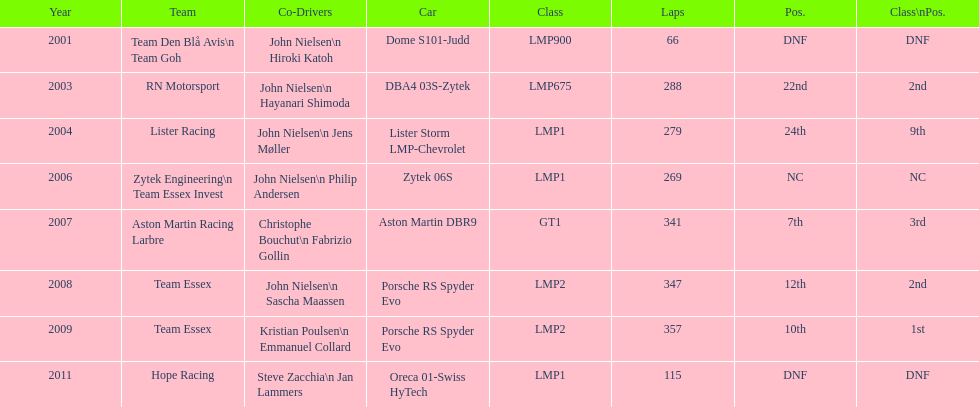What model car was the most used? Porsche RS Spyder. Could you parse the entire table? {'header': ['Year', 'Team', 'Co-Drivers', 'Car', 'Class', 'Laps', 'Pos.', 'Class\\nPos.'], 'rows': [['2001', 'Team Den Blå Avis\\n Team Goh', 'John Nielsen\\n Hiroki Katoh', 'Dome S101-Judd', 'LMP900', '66', 'DNF', 'DNF'], ['2003', 'RN Motorsport', 'John Nielsen\\n Hayanari Shimoda', 'DBA4 03S-Zytek', 'LMP675', '288', '22nd', '2nd'], ['2004', 'Lister Racing', 'John Nielsen\\n Jens Møller', 'Lister Storm LMP-Chevrolet', 'LMP1', '279', '24th', '9th'], ['2006', 'Zytek Engineering\\n Team Essex Invest', 'John Nielsen\\n Philip Andersen', 'Zytek 06S', 'LMP1', '269', 'NC', 'NC'], ['2007', 'Aston Martin Racing Larbre', 'Christophe Bouchut\\n Fabrizio Gollin', 'Aston Martin DBR9', 'GT1', '341', '7th', '3rd'], ['2008', 'Team Essex', 'John Nielsen\\n Sascha Maassen', 'Porsche RS Spyder Evo', 'LMP2', '347', '12th', '2nd'], ['2009', 'Team Essex', 'Kristian Poulsen\\n Emmanuel Collard', 'Porsche RS Spyder Evo', 'LMP2', '357', '10th', '1st'], ['2011', 'Hope Racing', 'Steve Zacchia\\n Jan Lammers', 'Oreca 01-Swiss HyTech', 'LMP1', '115', 'DNF', 'DNF']]} 